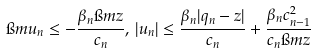<formula> <loc_0><loc_0><loc_500><loc_500>\i m u _ { n } \leq - \frac { \beta _ { n } \i m z } { c _ { n } } , \, | u _ { n } | \leq \frac { \beta _ { n } | q _ { n } - z | } { c _ { n } } + \frac { \beta _ { n } c _ { n - 1 } ^ { 2 } } { c _ { n } \i m z }</formula> 